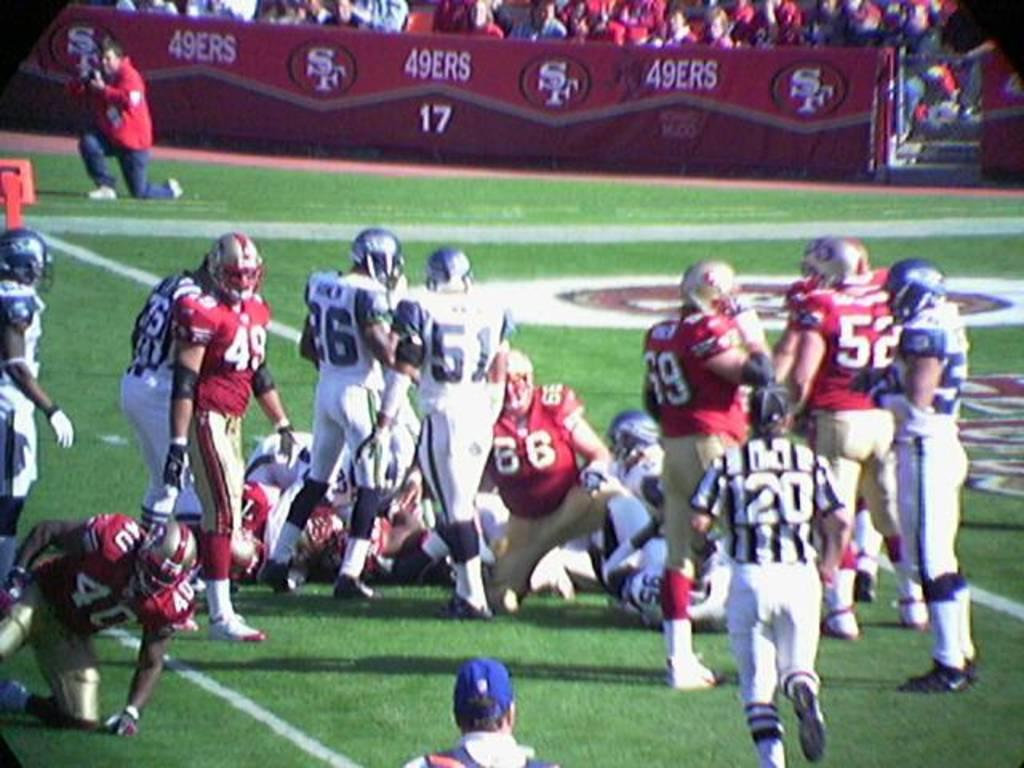What are the people in the image doing? There are people standing and sitting on the ground in the image. What can be seen in the background of the image? There are advertisement boards and spectators in the background of the image. What color is the blood on the flag in the image? There is no blood or flag present in the image. How does the stomach of the person sitting on the ground look like in the image? There is no information about the person's stomach visible in the image. 